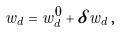<formula> <loc_0><loc_0><loc_500><loc_500>w _ { d } = w ^ { 0 } _ { d } + \delta w _ { d } \, ,</formula> 